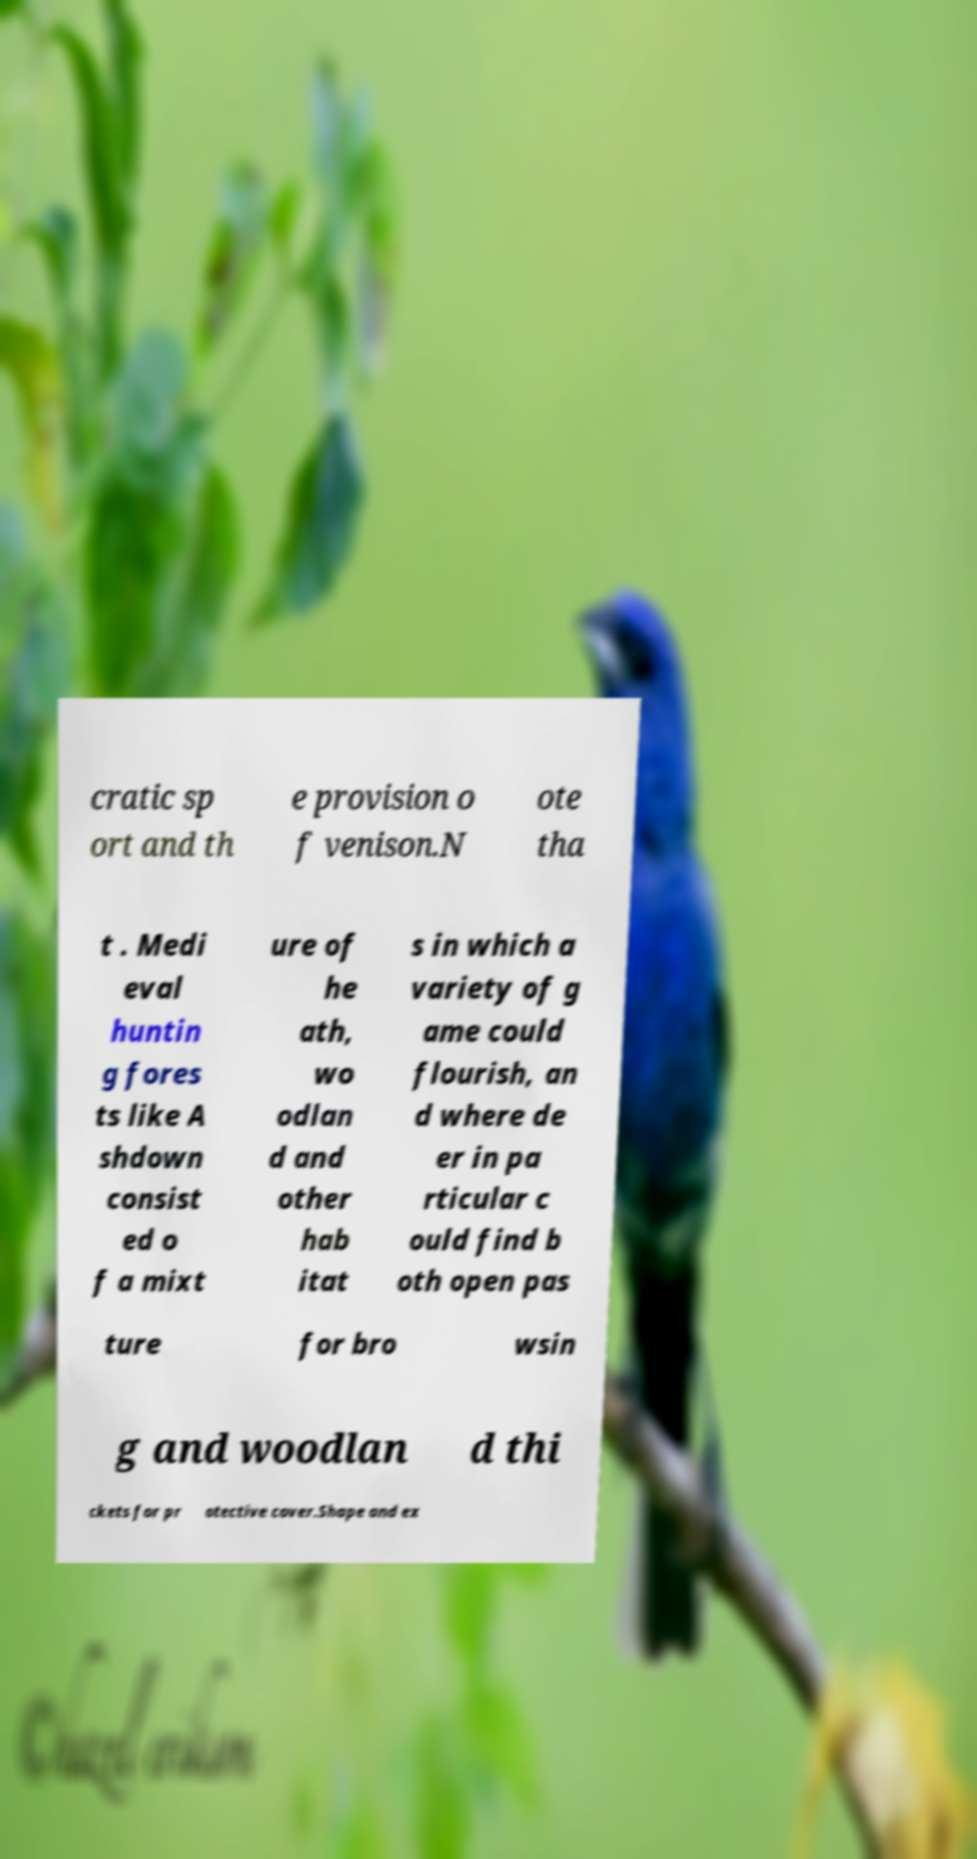For documentation purposes, I need the text within this image transcribed. Could you provide that? cratic sp ort and th e provision o f venison.N ote tha t . Medi eval huntin g fores ts like A shdown consist ed o f a mixt ure of he ath, wo odlan d and other hab itat s in which a variety of g ame could flourish, an d where de er in pa rticular c ould find b oth open pas ture for bro wsin g and woodlan d thi ckets for pr otective cover.Shape and ex 